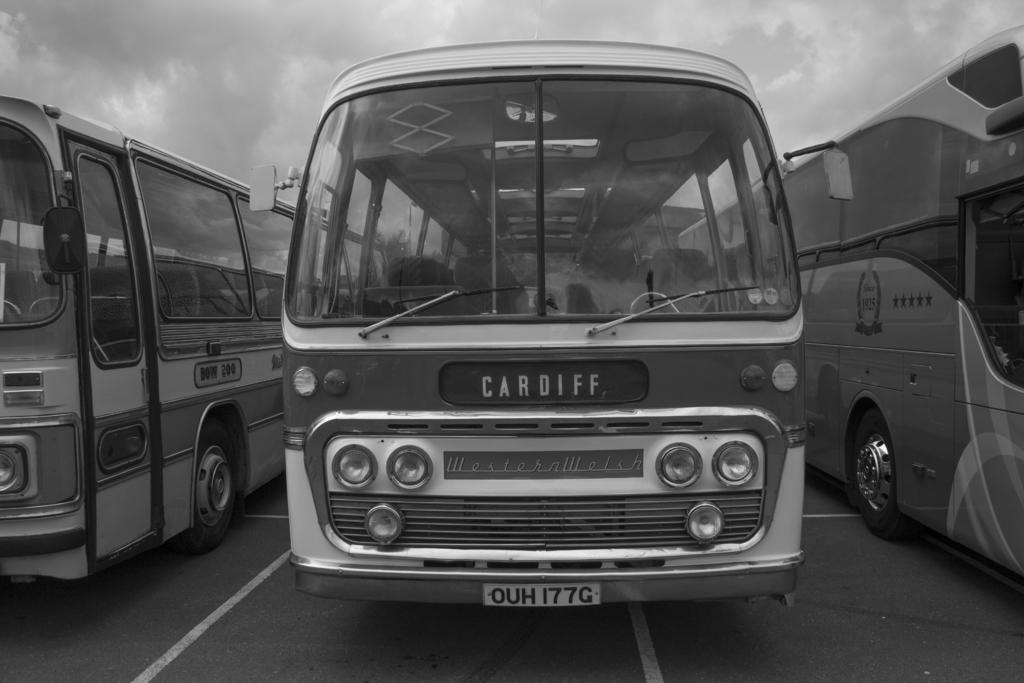<image>
Give a short and clear explanation of the subsequent image. A Cardiff bus is parked with other buses in a lot. 